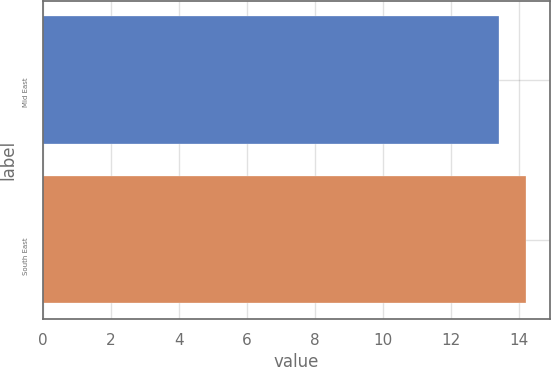<chart> <loc_0><loc_0><loc_500><loc_500><bar_chart><fcel>Mid East<fcel>South East<nl><fcel>13.4<fcel>14.2<nl></chart> 